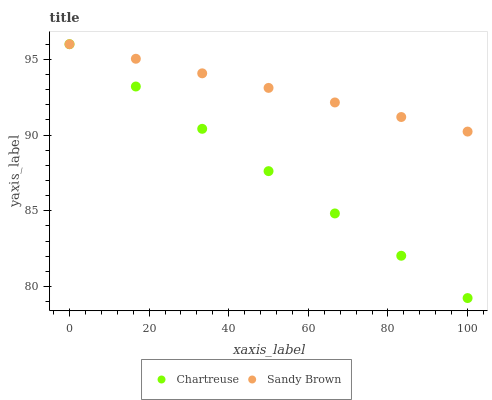Does Chartreuse have the minimum area under the curve?
Answer yes or no. Yes. Does Sandy Brown have the maximum area under the curve?
Answer yes or no. Yes. Does Sandy Brown have the minimum area under the curve?
Answer yes or no. No. Is Sandy Brown the smoothest?
Answer yes or no. Yes. Is Chartreuse the roughest?
Answer yes or no. Yes. Is Sandy Brown the roughest?
Answer yes or no. No. Does Chartreuse have the lowest value?
Answer yes or no. Yes. Does Sandy Brown have the lowest value?
Answer yes or no. No. Does Sandy Brown have the highest value?
Answer yes or no. Yes. Does Chartreuse intersect Sandy Brown?
Answer yes or no. Yes. Is Chartreuse less than Sandy Brown?
Answer yes or no. No. Is Chartreuse greater than Sandy Brown?
Answer yes or no. No. 